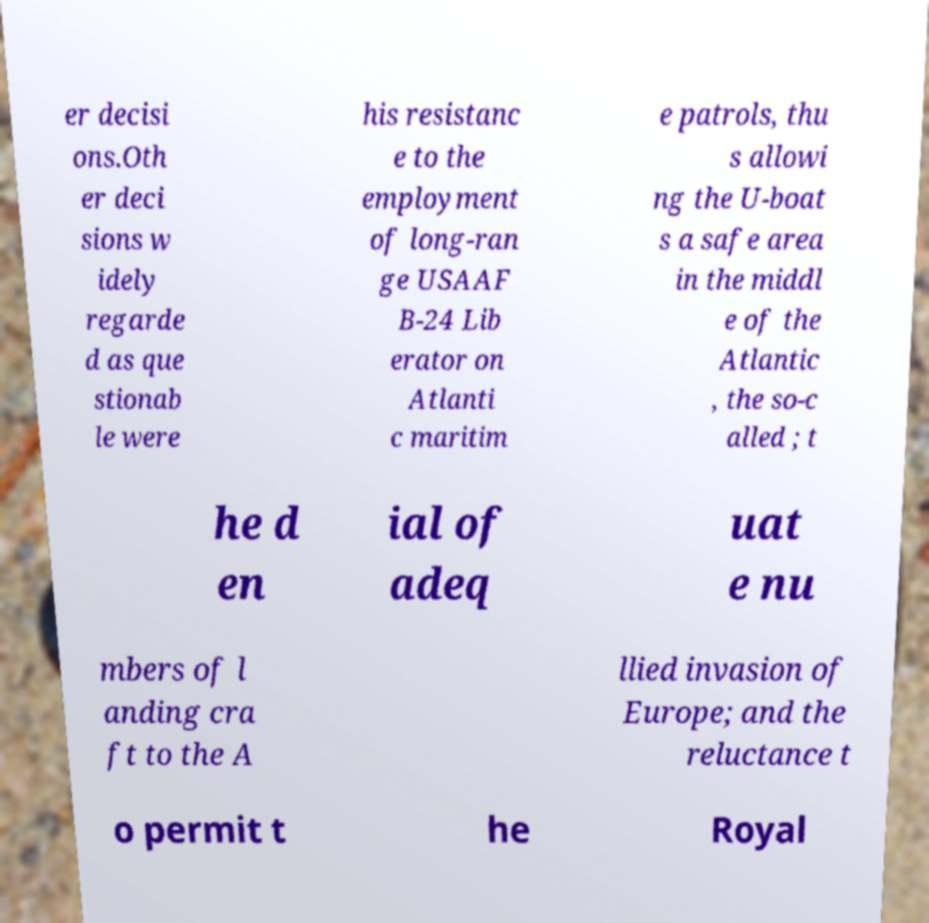I need the written content from this picture converted into text. Can you do that? er decisi ons.Oth er deci sions w idely regarde d as que stionab le were his resistanc e to the employment of long-ran ge USAAF B-24 Lib erator on Atlanti c maritim e patrols, thu s allowi ng the U-boat s a safe area in the middl e of the Atlantic , the so-c alled ; t he d en ial of adeq uat e nu mbers of l anding cra ft to the A llied invasion of Europe; and the reluctance t o permit t he Royal 